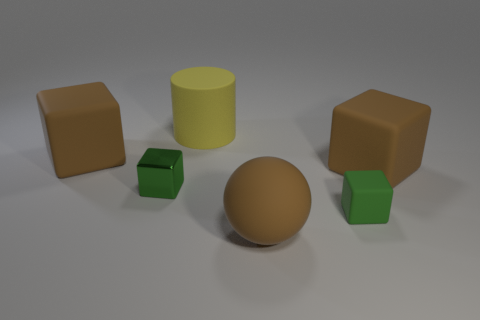Subtract all green matte blocks. How many blocks are left? 3 Add 3 small green metal cubes. How many objects exist? 9 Subtract all brown cubes. How many cubes are left? 2 Subtract all cubes. How many objects are left? 2 Subtract all tiny green spheres. Subtract all green matte blocks. How many objects are left? 5 Add 4 brown rubber objects. How many brown rubber objects are left? 7 Add 3 green cubes. How many green cubes exist? 5 Subtract 0 yellow cubes. How many objects are left? 6 Subtract 2 blocks. How many blocks are left? 2 Subtract all yellow balls. Subtract all brown cylinders. How many balls are left? 1 